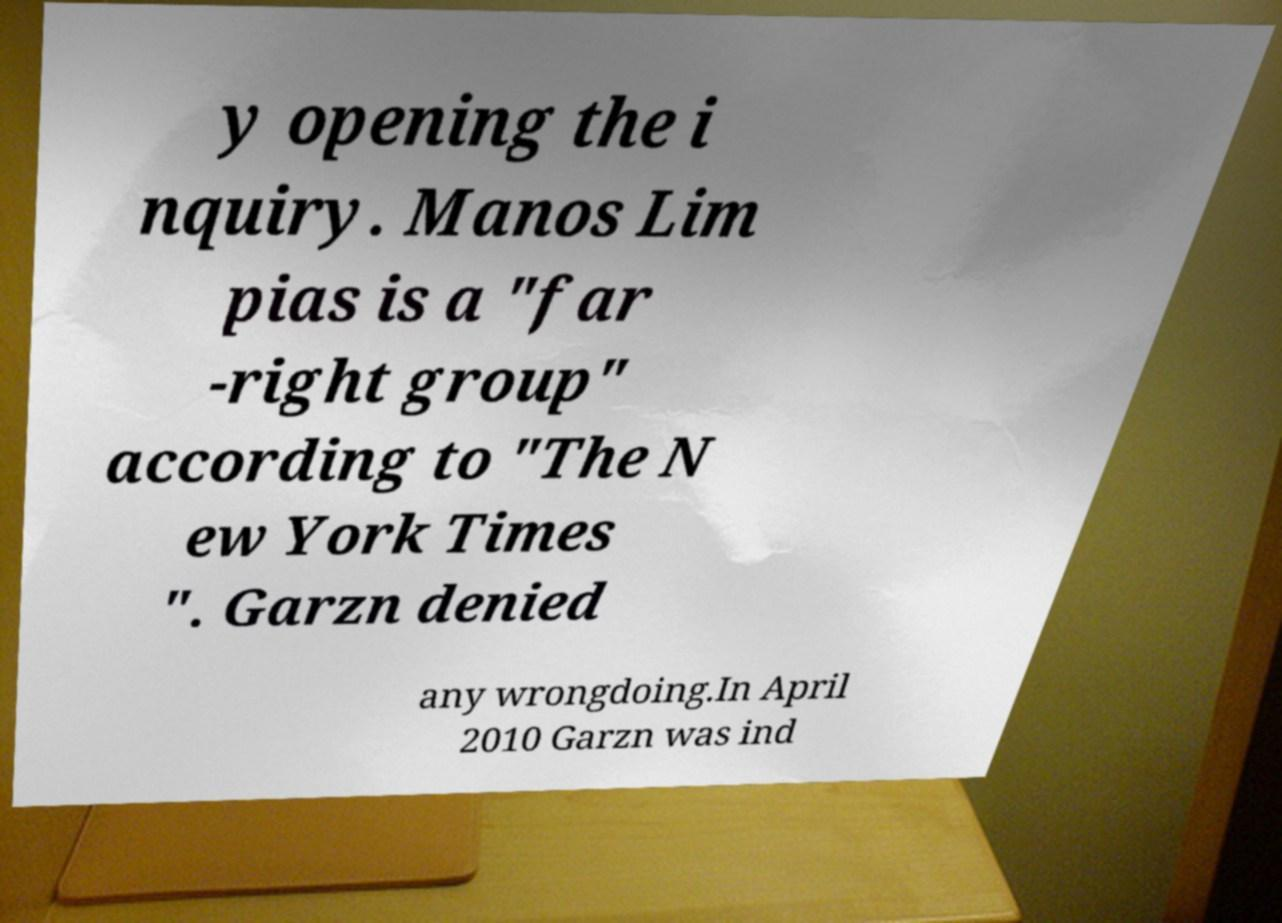What messages or text are displayed in this image? I need them in a readable, typed format. y opening the i nquiry. Manos Lim pias is a "far -right group" according to "The N ew York Times ". Garzn denied any wrongdoing.In April 2010 Garzn was ind 